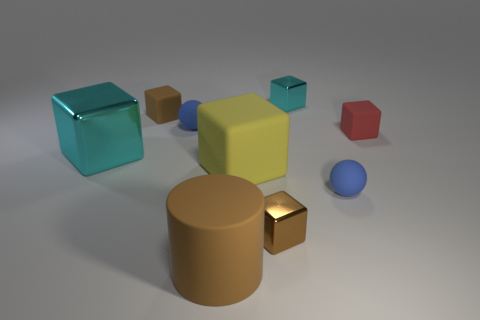What time of day does the lighting in the image suggest? The lighting in the image appears soft and diffused, with shadows that don't seem very sharp or pronounced. This suggests an indoor setting with artificial lighting, rather than natural sunlight at a specific time of day. The light source seems to be coming from above, gently illuminating the objects and creating subtle shadows on the ground. 